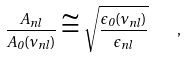<formula> <loc_0><loc_0><loc_500><loc_500>\frac { A _ { n l } } { A _ { 0 } ( \nu _ { n l } ) } \cong \sqrt { \frac { \epsilon _ { 0 } ( \nu _ { n l } ) } { \epsilon _ { n l } } } \quad ,</formula> 